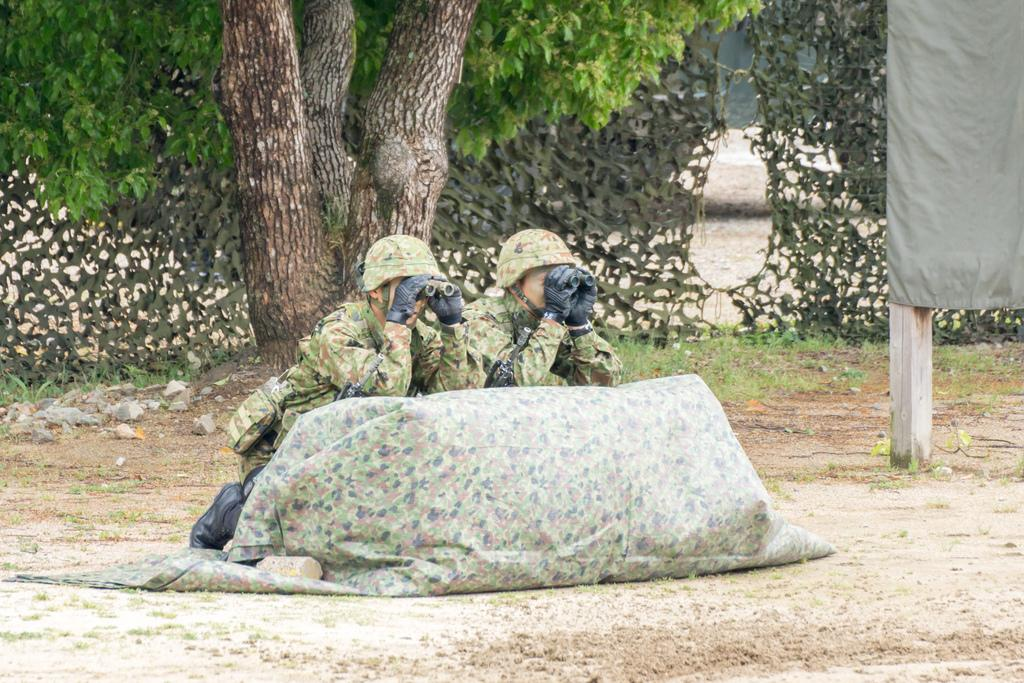How many people are in the image? There are two persons in the image. What are the persons holding in the image? The persons are holding binocular telescopes. What type of clothing can be seen in the image? Clothes are visible in the image. What is the ground like in the image? The ground is visible in the image, and it appears to be covered with stones and grass. What type of structure is present in the image? There is a wooden pole in the image. What type of vegetation is present in the image? There is a tree and plants visible in the image. What type of government is depicted in the image? There is no depiction of a government in the image; it features two persons holding binocular telescopes and various natural elements. What type of crow is visible in the image? There are no crows present in the image; it features a tree, plants, and other natural elements. 